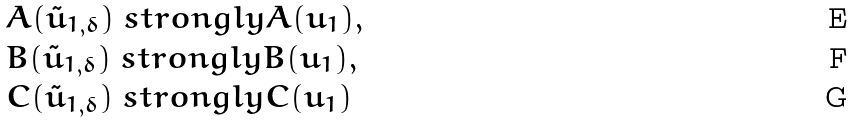<formula> <loc_0><loc_0><loc_500><loc_500>& A ( \tilde { u } _ { 1 , \delta } ) \ s t r o n g l y A ( u _ { 1 } ) , \\ & B ( \tilde { u } _ { 1 , \delta } ) \ s t r o n g l y B ( u _ { 1 } ) , \\ & C ( \tilde { u } _ { 1 , \delta } ) \ s t r o n g l y C ( u _ { 1 } )</formula> 